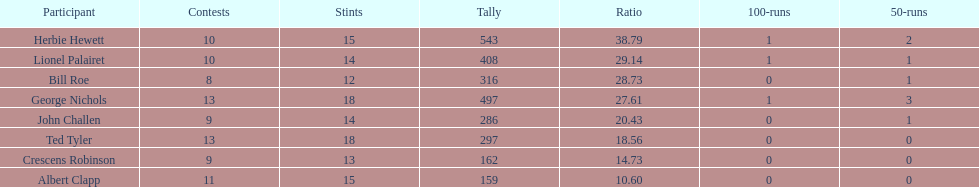Which player had the least amount of runs? Albert Clapp. 